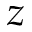<formula> <loc_0><loc_0><loc_500><loc_500>z</formula> 